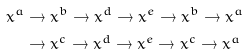Convert formula to latex. <formula><loc_0><loc_0><loc_500><loc_500>x ^ { a } & \rightarrow x ^ { b } \rightarrow x ^ { d } \rightarrow x ^ { e } \rightarrow x ^ { b } \rightarrow x ^ { a } \\ & \rightarrow x ^ { c } \rightarrow x ^ { d } \rightarrow x ^ { e } \rightarrow x ^ { c } \rightarrow x ^ { a }</formula> 